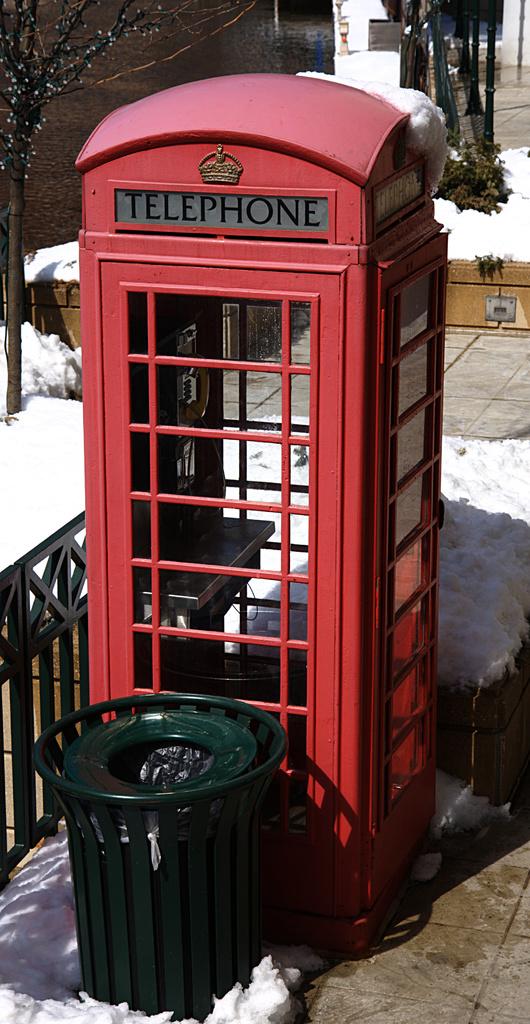What type of booth is this?
Your answer should be very brief. Telephone. What color is the booth?
Provide a short and direct response. Answering does not require reading text in the image. 